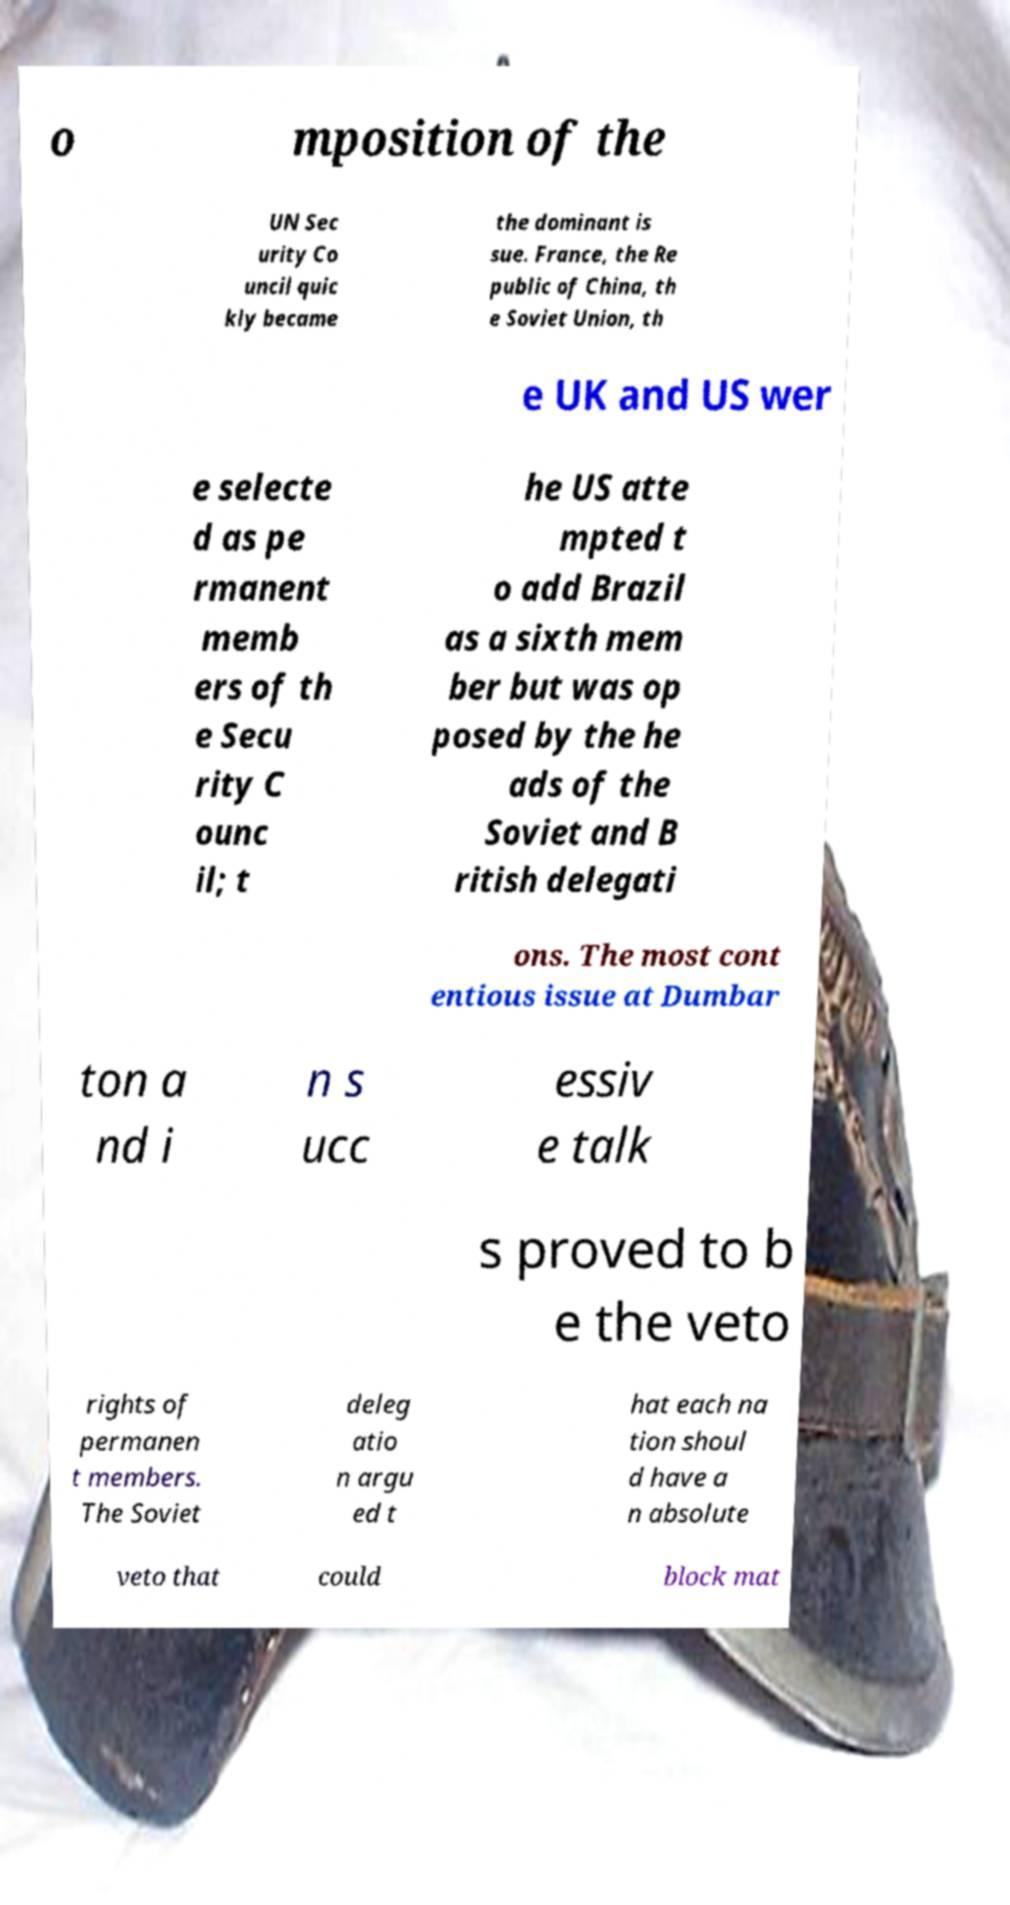Please read and relay the text visible in this image. What does it say? o mposition of the UN Sec urity Co uncil quic kly became the dominant is sue. France, the Re public of China, th e Soviet Union, th e UK and US wer e selecte d as pe rmanent memb ers of th e Secu rity C ounc il; t he US atte mpted t o add Brazil as a sixth mem ber but was op posed by the he ads of the Soviet and B ritish delegati ons. The most cont entious issue at Dumbar ton a nd i n s ucc essiv e talk s proved to b e the veto rights of permanen t members. The Soviet deleg atio n argu ed t hat each na tion shoul d have a n absolute veto that could block mat 